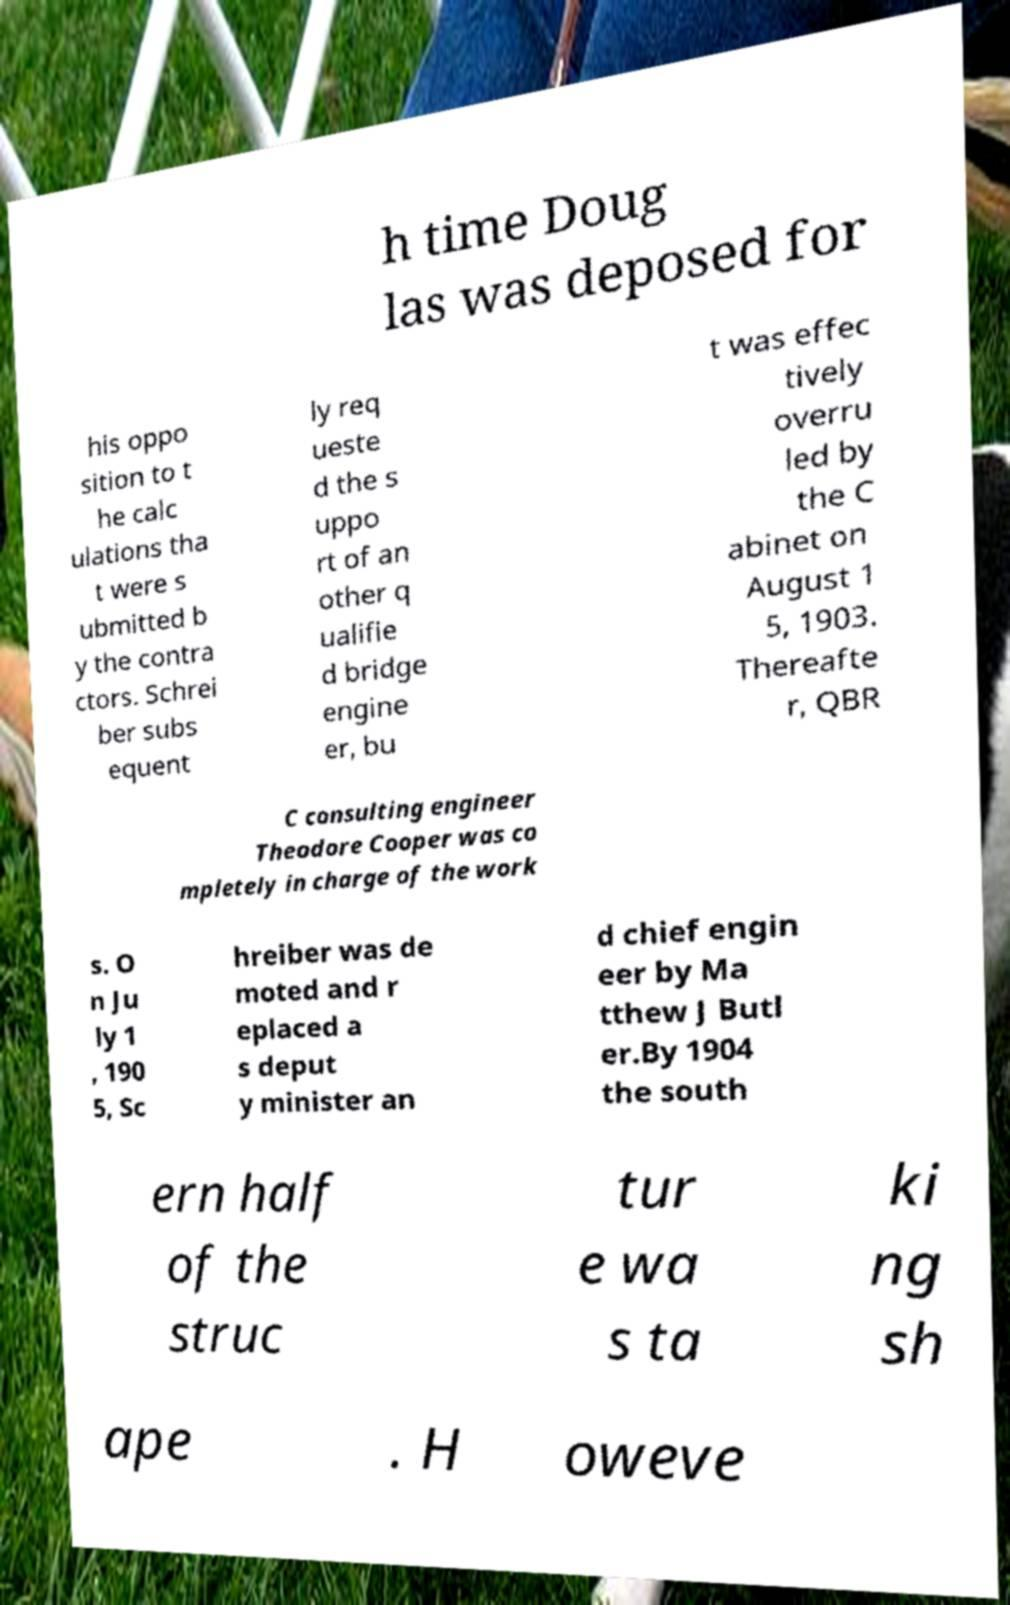What messages or text are displayed in this image? I need them in a readable, typed format. h time Doug las was deposed for his oppo sition to t he calc ulations tha t were s ubmitted b y the contra ctors. Schrei ber subs equent ly req ueste d the s uppo rt of an other q ualifie d bridge engine er, bu t was effec tively overru led by the C abinet on August 1 5, 1903. Thereafte r, QBR C consulting engineer Theodore Cooper was co mpletely in charge of the work s. O n Ju ly 1 , 190 5, Sc hreiber was de moted and r eplaced a s deput y minister an d chief engin eer by Ma tthew J Butl er.By 1904 the south ern half of the struc tur e wa s ta ki ng sh ape . H oweve 